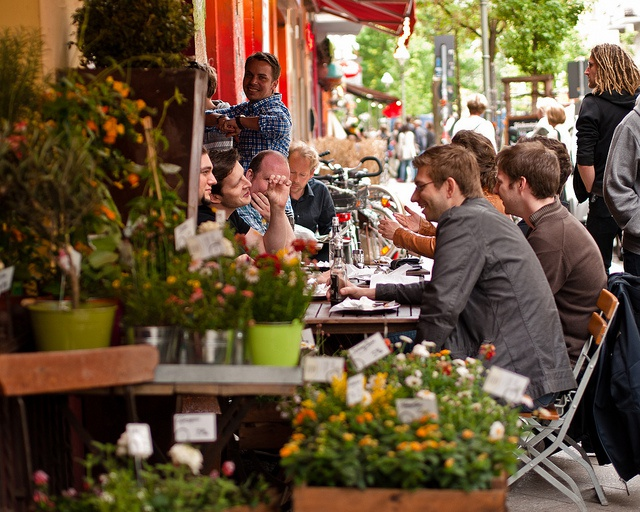Describe the objects in this image and their specific colors. I can see potted plant in olive, black, brown, and darkgray tones, people in olive, gray, black, and maroon tones, potted plant in olive, black, maroon, and brown tones, potted plant in olive, black, and maroon tones, and people in olive, black, maroon, and brown tones in this image. 